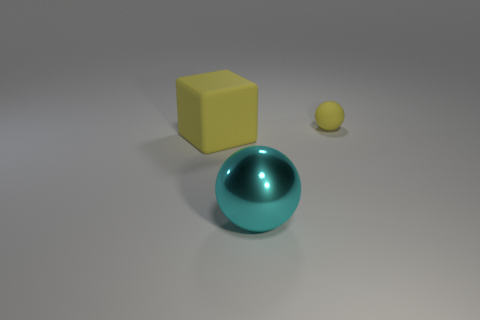Add 3 metal things. How many objects exist? 6 Subtract all balls. How many objects are left? 1 Add 1 big yellow blocks. How many big yellow blocks are left? 2 Add 1 large yellow cubes. How many large yellow cubes exist? 2 Subtract 0 blue blocks. How many objects are left? 3 Subtract all big things. Subtract all large cyan metal objects. How many objects are left? 0 